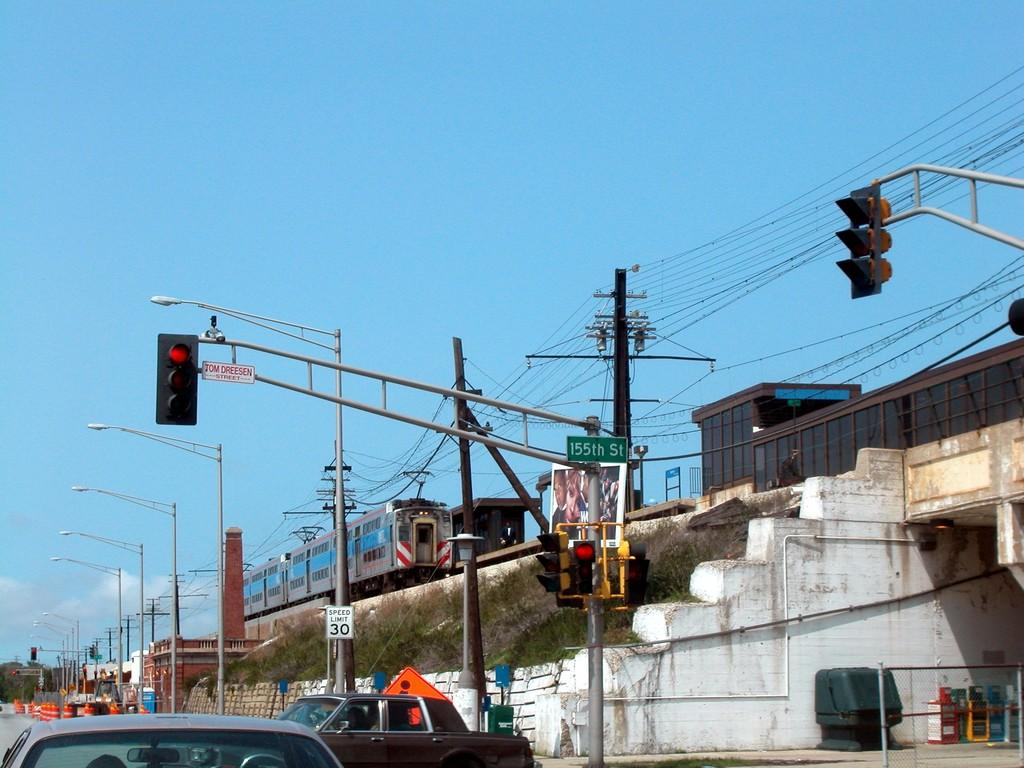<image>
Present a compact description of the photo's key features. A red stop light that is on a sign for 155th Street. 